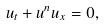Convert formula to latex. <formula><loc_0><loc_0><loc_500><loc_500>u _ { t } + u ^ { n } u _ { x } = 0 ,</formula> 